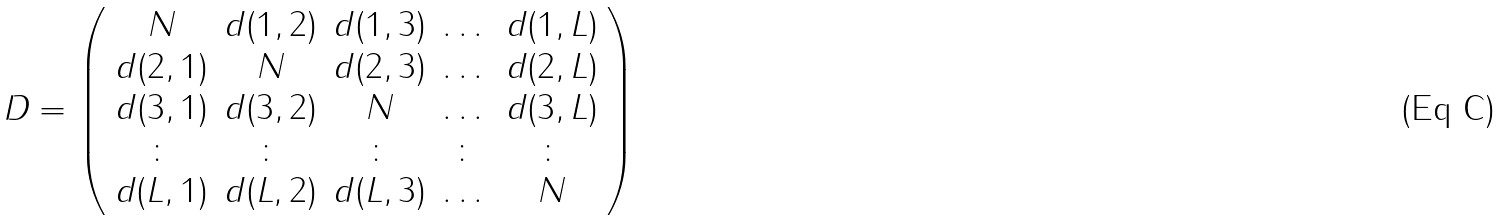Convert formula to latex. <formula><loc_0><loc_0><loc_500><loc_500>D = \left ( \begin{array} { c c c c c } N & d ( 1 , 2 ) & d ( 1 , 3 ) & \dots & d ( 1 , L ) \\ d ( 2 , 1 ) & N & d ( 2 , 3 ) & \dots & d ( 2 , L ) \\ d ( 3 , 1 ) & d ( 3 , 2 ) & N & \dots & d ( 3 , L ) \\ \colon & \colon & \colon & \colon & \colon \\ d ( L , 1 ) & d ( L , 2 ) & d ( L , 3 ) & \dots & N \end{array} \right )</formula> 